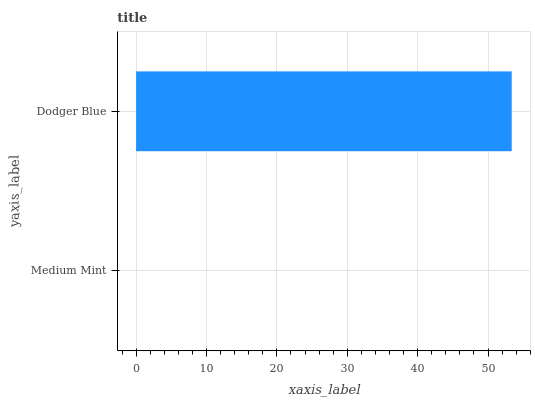Is Medium Mint the minimum?
Answer yes or no. Yes. Is Dodger Blue the maximum?
Answer yes or no. Yes. Is Dodger Blue the minimum?
Answer yes or no. No. Is Dodger Blue greater than Medium Mint?
Answer yes or no. Yes. Is Medium Mint less than Dodger Blue?
Answer yes or no. Yes. Is Medium Mint greater than Dodger Blue?
Answer yes or no. No. Is Dodger Blue less than Medium Mint?
Answer yes or no. No. Is Dodger Blue the high median?
Answer yes or no. Yes. Is Medium Mint the low median?
Answer yes or no. Yes. Is Medium Mint the high median?
Answer yes or no. No. Is Dodger Blue the low median?
Answer yes or no. No. 